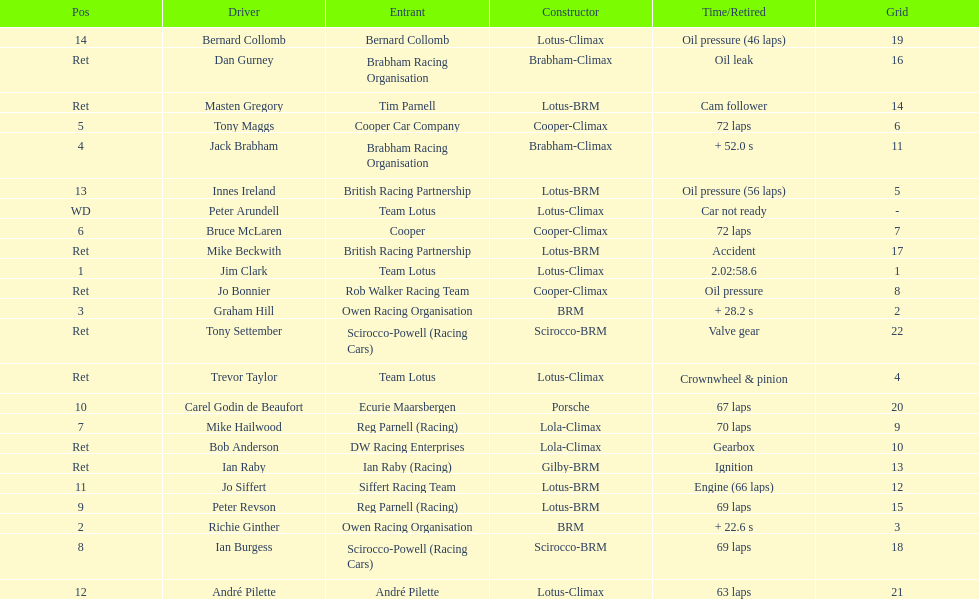Who was the top finisher that drove a cooper-climax? Tony Maggs. 